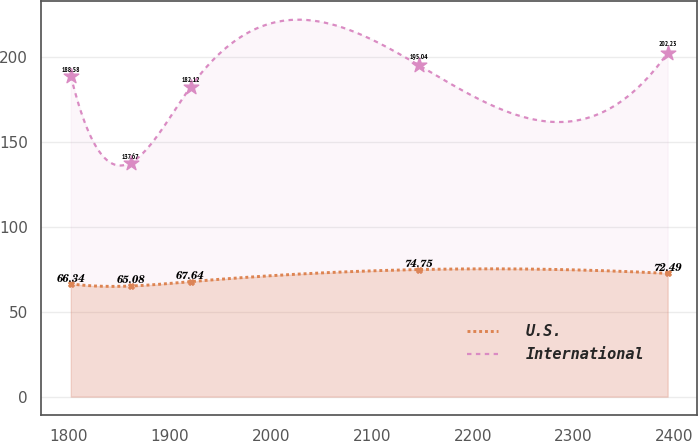<chart> <loc_0><loc_0><loc_500><loc_500><line_chart><ecel><fcel>U.S.<fcel>International<nl><fcel>1801.78<fcel>66.34<fcel>188.58<nl><fcel>1861.27<fcel>65.08<fcel>137.67<nl><fcel>1920.42<fcel>67.64<fcel>182.12<nl><fcel>2146.44<fcel>74.75<fcel>195.04<nl><fcel>2393.25<fcel>72.49<fcel>202.23<nl></chart> 